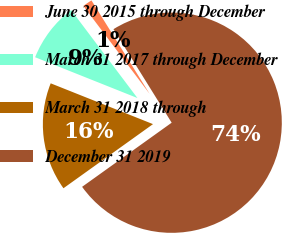<chart> <loc_0><loc_0><loc_500><loc_500><pie_chart><fcel>June 30 2015 through December<fcel>March 31 2017 through December<fcel>March 31 2018 through<fcel>December 31 2019<nl><fcel>1.42%<fcel>8.68%<fcel>15.93%<fcel>73.97%<nl></chart> 